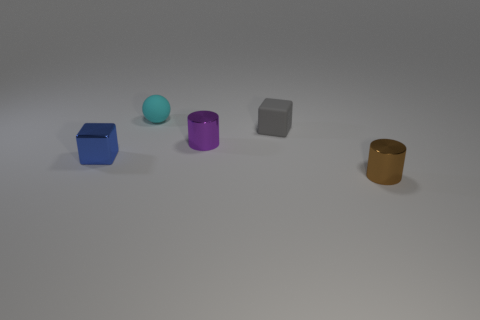Do the cylinder behind the small blue shiny cube and the cube that is right of the tiny blue metallic object have the same material?
Offer a very short reply. No. Is the block that is in front of the small gray thing made of the same material as the small gray object?
Your answer should be compact. No. What is the color of the shiny block?
Offer a very short reply. Blue. What color is the tiny shiny thing that is both right of the blue shiny block and left of the small gray matte thing?
Your response must be concise. Purple. There is a small metal thing right of the cylinder behind the cylinder that is to the right of the small matte block; what color is it?
Provide a short and direct response. Brown. What is the color of the rubber ball that is the same size as the purple thing?
Ensure brevity in your answer.  Cyan. What is the shape of the shiny object that is to the right of the small cylinder behind the tiny cylinder that is right of the small gray object?
Offer a very short reply. Cylinder. What number of objects are either large blue cylinders or small cubes that are on the right side of the small purple object?
Keep it short and to the point. 1. There is a cube that is to the right of the sphere; what is it made of?
Provide a short and direct response. Rubber. Is the number of small purple cylinders that are right of the small brown object the same as the number of tiny brown things that are on the left side of the small rubber sphere?
Provide a succinct answer. Yes. 